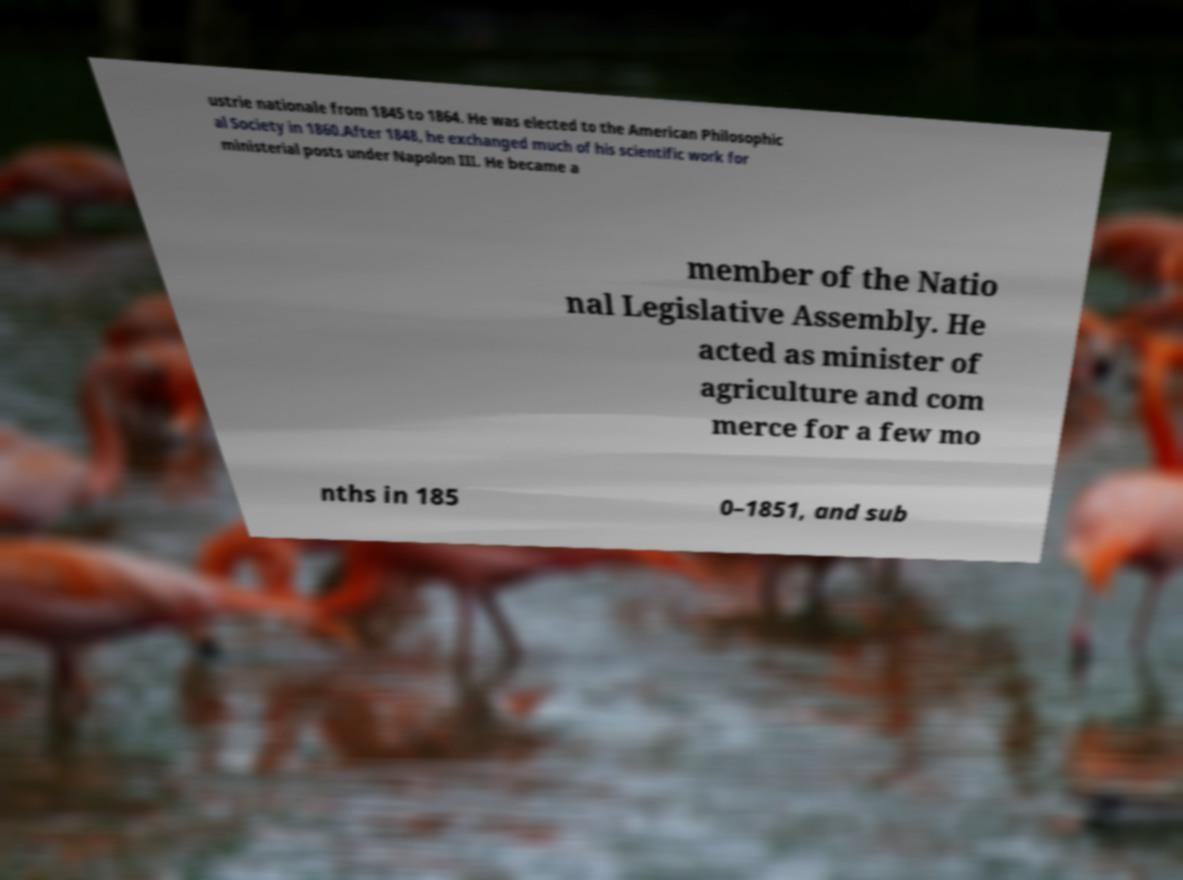For documentation purposes, I need the text within this image transcribed. Could you provide that? ustrie nationale from 1845 to 1864. He was elected to the American Philosophic al Society in 1860.After 1848, he exchanged much of his scientific work for ministerial posts under Napolon III. He became a member of the Natio nal Legislative Assembly. He acted as minister of agriculture and com merce for a few mo nths in 185 0–1851, and sub 